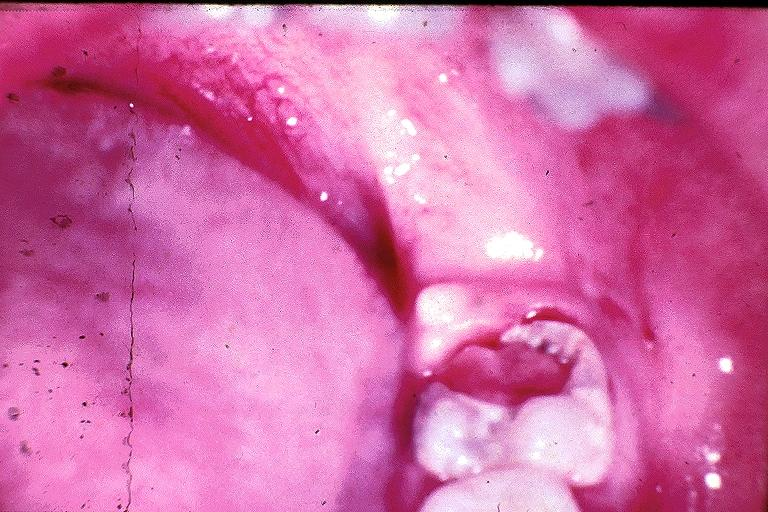does myelomonocytic leukemia show chronic hyperplastic pulpitis?
Answer the question using a single word or phrase. No 